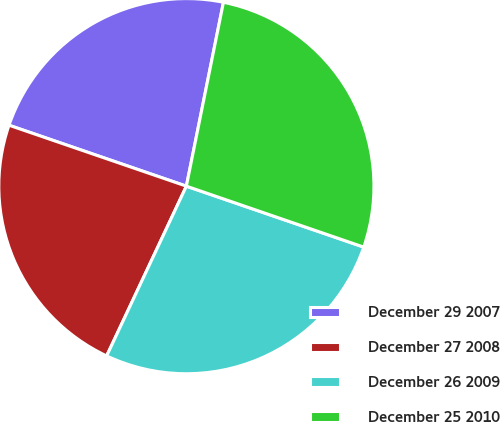<chart> <loc_0><loc_0><loc_500><loc_500><pie_chart><fcel>December 29 2007<fcel>December 27 2008<fcel>December 26 2009<fcel>December 25 2010<nl><fcel>22.9%<fcel>23.28%<fcel>26.72%<fcel>27.1%<nl></chart> 